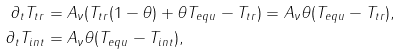<formula> <loc_0><loc_0><loc_500><loc_500>\partial _ { t } T _ { t r } & = A _ { \nu } ( T _ { t r } ( 1 - \theta ) + \theta T _ { e q u } - T _ { t r } ) = A _ { \nu } \theta ( T _ { e q u } - T _ { t r } ) , \\ \partial _ { t } T _ { i n t } & = A _ { \nu } \theta ( T _ { e q u } - T _ { i n t } ) ,</formula> 